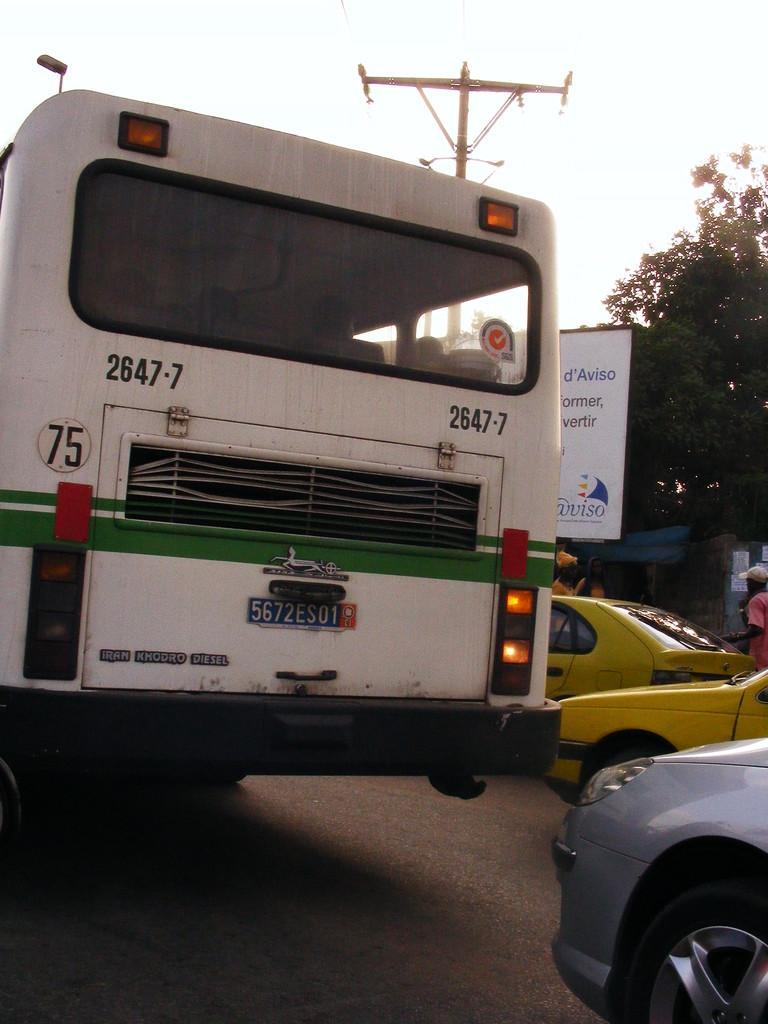Provide a one-sentence caption for the provided image. road scene with a back of a bus number 75. 